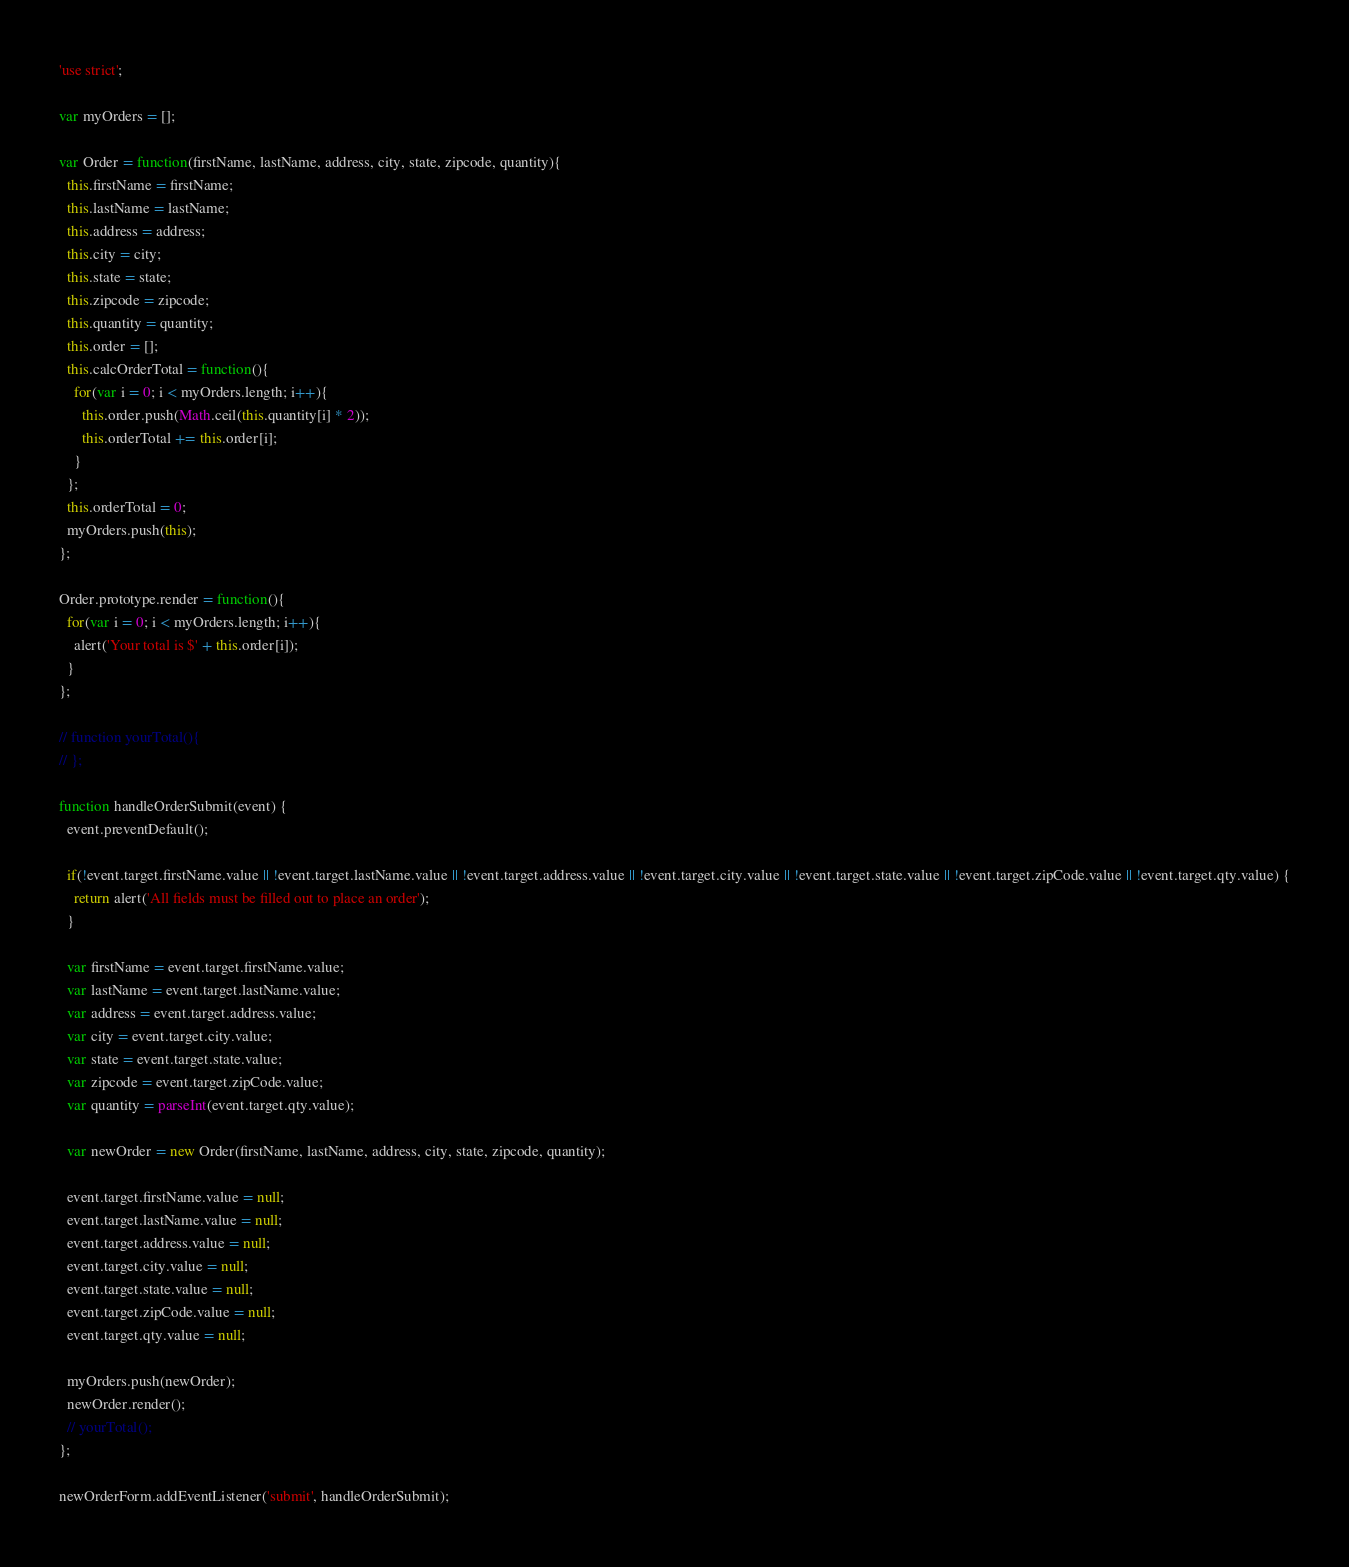<code> <loc_0><loc_0><loc_500><loc_500><_JavaScript_>'use strict';

var myOrders = [];

var Order = function(firstName, lastName, address, city, state, zipcode, quantity){
  this.firstName = firstName;
  this.lastName = lastName;
  this.address = address;
  this.city = city;
  this.state = state;
  this.zipcode = zipcode;
  this.quantity = quantity;
  this.order = [];
  this.calcOrderTotal = function(){
    for(var i = 0; i < myOrders.length; i++){
      this.order.push(Math.ceil(this.quantity[i] * 2));
      this.orderTotal += this.order[i];
    }
  };
  this.orderTotal = 0;
  myOrders.push(this);
};

Order.prototype.render = function(){
  for(var i = 0; i < myOrders.length; i++){
    alert('Your total is $' + this.order[i]);
  }
};

// function yourTotal(){
// };

function handleOrderSubmit(event) {
  event.preventDefault();

  if(!event.target.firstName.value || !event.target.lastName.value || !event.target.address.value || !event.target.city.value || !event.target.state.value || !event.target.zipCode.value || !event.target.qty.value) {
    return alert('All fields must be filled out to place an order');
  }

  var firstName = event.target.firstName.value;
  var lastName = event.target.lastName.value;
  var address = event.target.address.value;
  var city = event.target.city.value;
  var state = event.target.state.value;
  var zipcode = event.target.zipCode.value;
  var quantity = parseInt(event.target.qty.value);

  var newOrder = new Order(firstName, lastName, address, city, state, zipcode, quantity);

  event.target.firstName.value = null;
  event.target.lastName.value = null;
  event.target.address.value = null;
  event.target.city.value = null;
  event.target.state.value = null;
  event.target.zipCode.value = null;
  event.target.qty.value = null;

  myOrders.push(newOrder);
  newOrder.render();
  // yourTotal();
};

newOrderForm.addEventListener('submit', handleOrderSubmit);
</code> 